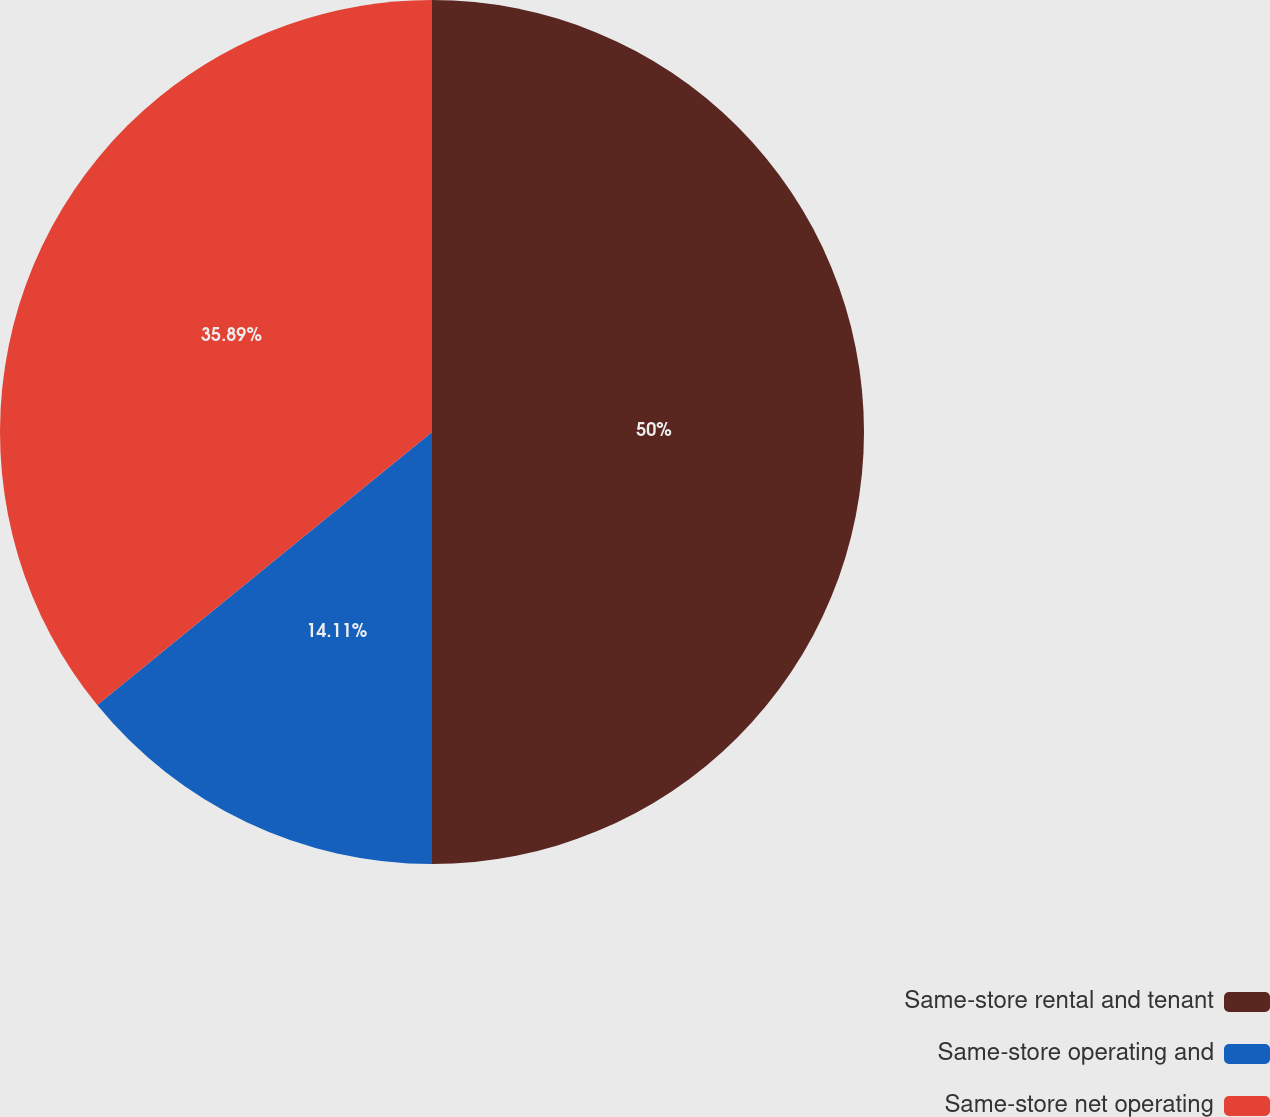Convert chart. <chart><loc_0><loc_0><loc_500><loc_500><pie_chart><fcel>Same-store rental and tenant<fcel>Same-store operating and<fcel>Same-store net operating<nl><fcel>50.0%<fcel>14.11%<fcel>35.89%<nl></chart> 